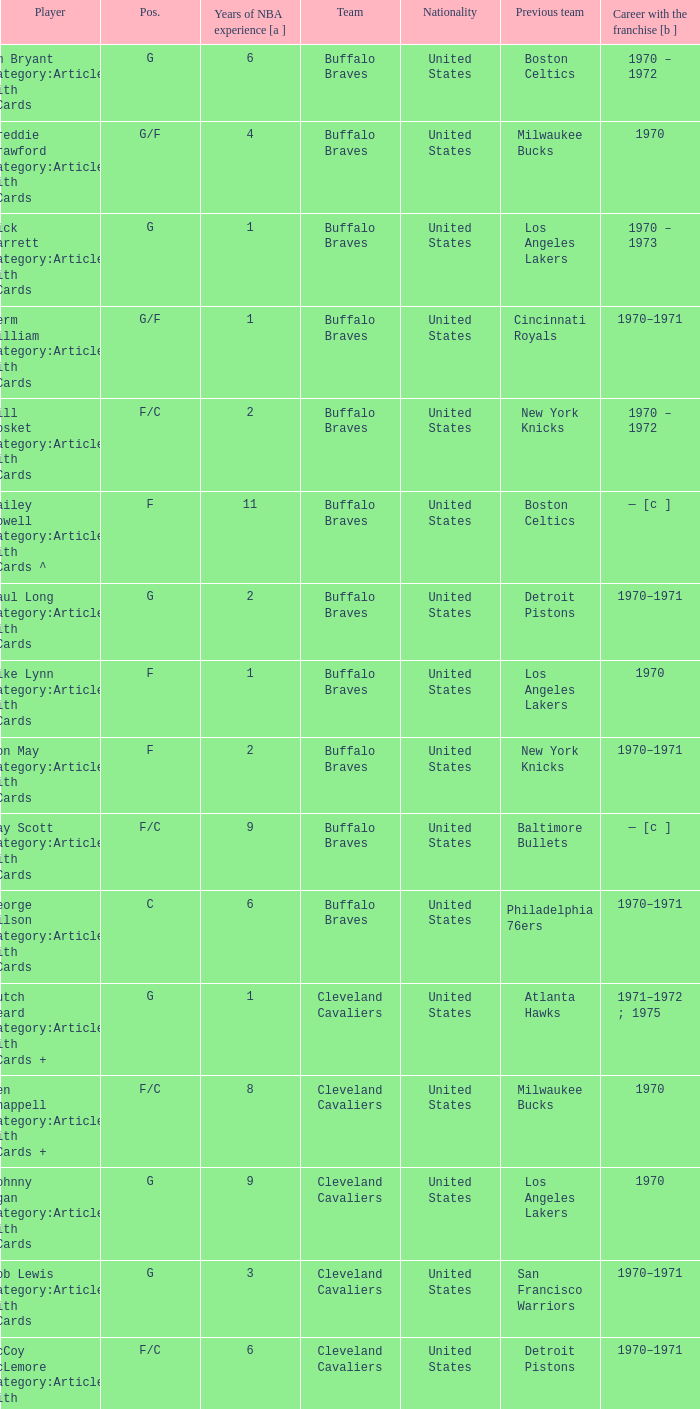How many years of NBA experience does the player who plays position g for the Portland Trail Blazers? 2.0. 